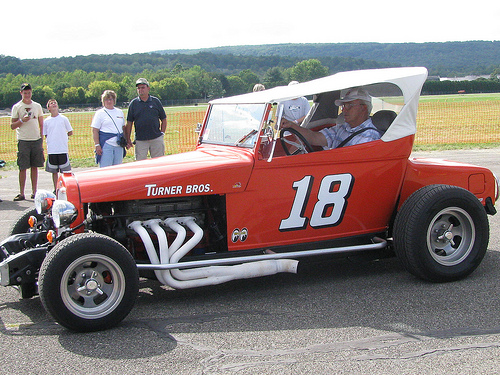<image>
Can you confirm if the man is behind the car? Yes. From this viewpoint, the man is positioned behind the car, with the car partially or fully occluding the man. 